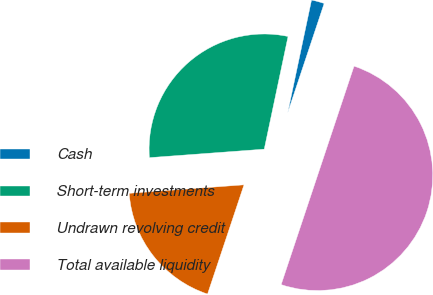<chart> <loc_0><loc_0><loc_500><loc_500><pie_chart><fcel>Cash<fcel>Short-term investments<fcel>Undrawn revolving credit<fcel>Total available liquidity<nl><fcel>1.81%<fcel>29.49%<fcel>18.7%<fcel>50.0%<nl></chart> 